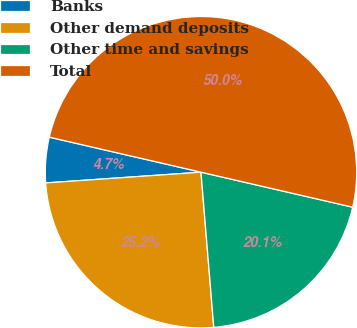Convert chart to OTSL. <chart><loc_0><loc_0><loc_500><loc_500><pie_chart><fcel>Banks<fcel>Other demand deposits<fcel>Other time and savings<fcel>Total<nl><fcel>4.71%<fcel>25.21%<fcel>20.08%<fcel>50.0%<nl></chart> 